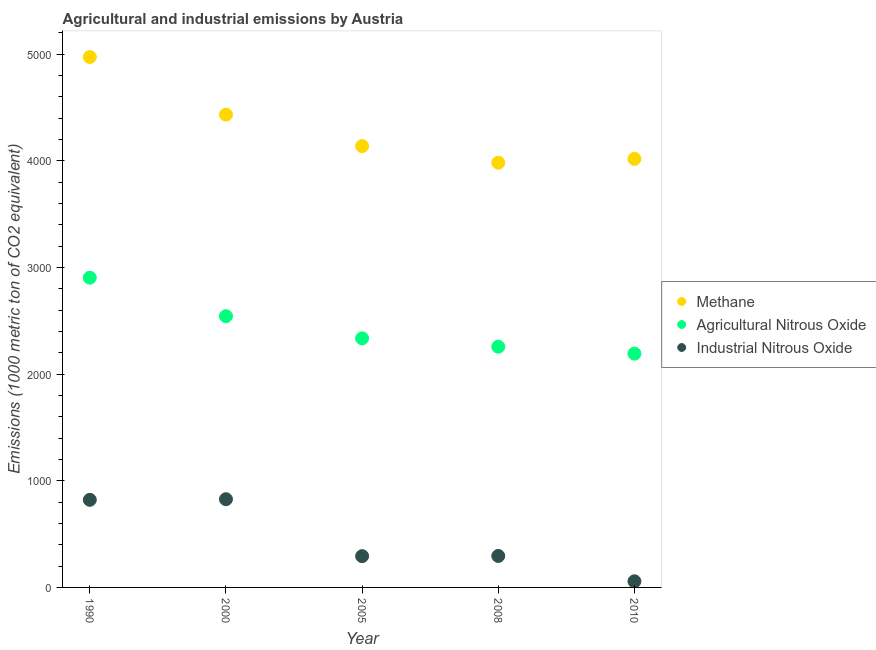What is the amount of agricultural nitrous oxide emissions in 2005?
Offer a very short reply. 2335.7. Across all years, what is the maximum amount of methane emissions?
Offer a terse response. 4973.8. Across all years, what is the minimum amount of agricultural nitrous oxide emissions?
Ensure brevity in your answer.  2192.3. In which year was the amount of methane emissions minimum?
Your answer should be compact. 2008. What is the total amount of industrial nitrous oxide emissions in the graph?
Make the answer very short. 2294.7. What is the difference between the amount of industrial nitrous oxide emissions in 2000 and that in 2008?
Provide a succinct answer. 532. What is the difference between the amount of industrial nitrous oxide emissions in 2000 and the amount of methane emissions in 2008?
Keep it short and to the point. -3155.6. What is the average amount of methane emissions per year?
Keep it short and to the point. 4309.52. In the year 1990, what is the difference between the amount of industrial nitrous oxide emissions and amount of methane emissions?
Offer a terse response. -4152.3. In how many years, is the amount of industrial nitrous oxide emissions greater than 3000 metric ton?
Your answer should be compact. 0. What is the ratio of the amount of methane emissions in 2005 to that in 2008?
Your answer should be very brief. 1.04. Is the amount of methane emissions in 1990 less than that in 2010?
Provide a succinct answer. No. What is the difference between the highest and the second highest amount of methane emissions?
Offer a terse response. 539.9. What is the difference between the highest and the lowest amount of industrial nitrous oxide emissions?
Provide a succinct answer. 769.7. In how many years, is the amount of industrial nitrous oxide emissions greater than the average amount of industrial nitrous oxide emissions taken over all years?
Your answer should be compact. 2. Is the amount of industrial nitrous oxide emissions strictly greater than the amount of methane emissions over the years?
Keep it short and to the point. No. How many dotlines are there?
Provide a short and direct response. 3. How many years are there in the graph?
Keep it short and to the point. 5. Are the values on the major ticks of Y-axis written in scientific E-notation?
Offer a very short reply. No. Does the graph contain grids?
Provide a short and direct response. No. Where does the legend appear in the graph?
Your answer should be very brief. Center right. How many legend labels are there?
Your response must be concise. 3. How are the legend labels stacked?
Your answer should be very brief. Vertical. What is the title of the graph?
Your answer should be very brief. Agricultural and industrial emissions by Austria. What is the label or title of the Y-axis?
Offer a terse response. Emissions (1000 metric ton of CO2 equivalent). What is the Emissions (1000 metric ton of CO2 equivalent) of Methane in 1990?
Keep it short and to the point. 4973.8. What is the Emissions (1000 metric ton of CO2 equivalent) in Agricultural Nitrous Oxide in 1990?
Your answer should be compact. 2904.8. What is the Emissions (1000 metric ton of CO2 equivalent) in Industrial Nitrous Oxide in 1990?
Your answer should be very brief. 821.5. What is the Emissions (1000 metric ton of CO2 equivalent) in Methane in 2000?
Make the answer very short. 4433.9. What is the Emissions (1000 metric ton of CO2 equivalent) of Agricultural Nitrous Oxide in 2000?
Your response must be concise. 2543.3. What is the Emissions (1000 metric ton of CO2 equivalent) of Industrial Nitrous Oxide in 2000?
Offer a very short reply. 827.2. What is the Emissions (1000 metric ton of CO2 equivalent) of Methane in 2005?
Offer a terse response. 4138.3. What is the Emissions (1000 metric ton of CO2 equivalent) of Agricultural Nitrous Oxide in 2005?
Provide a short and direct response. 2335.7. What is the Emissions (1000 metric ton of CO2 equivalent) of Industrial Nitrous Oxide in 2005?
Make the answer very short. 293.3. What is the Emissions (1000 metric ton of CO2 equivalent) of Methane in 2008?
Your answer should be compact. 3982.8. What is the Emissions (1000 metric ton of CO2 equivalent) in Agricultural Nitrous Oxide in 2008?
Ensure brevity in your answer.  2257.3. What is the Emissions (1000 metric ton of CO2 equivalent) of Industrial Nitrous Oxide in 2008?
Make the answer very short. 295.2. What is the Emissions (1000 metric ton of CO2 equivalent) in Methane in 2010?
Ensure brevity in your answer.  4018.8. What is the Emissions (1000 metric ton of CO2 equivalent) in Agricultural Nitrous Oxide in 2010?
Ensure brevity in your answer.  2192.3. What is the Emissions (1000 metric ton of CO2 equivalent) of Industrial Nitrous Oxide in 2010?
Provide a succinct answer. 57.5. Across all years, what is the maximum Emissions (1000 metric ton of CO2 equivalent) in Methane?
Provide a short and direct response. 4973.8. Across all years, what is the maximum Emissions (1000 metric ton of CO2 equivalent) in Agricultural Nitrous Oxide?
Give a very brief answer. 2904.8. Across all years, what is the maximum Emissions (1000 metric ton of CO2 equivalent) of Industrial Nitrous Oxide?
Offer a very short reply. 827.2. Across all years, what is the minimum Emissions (1000 metric ton of CO2 equivalent) of Methane?
Give a very brief answer. 3982.8. Across all years, what is the minimum Emissions (1000 metric ton of CO2 equivalent) of Agricultural Nitrous Oxide?
Give a very brief answer. 2192.3. Across all years, what is the minimum Emissions (1000 metric ton of CO2 equivalent) of Industrial Nitrous Oxide?
Offer a terse response. 57.5. What is the total Emissions (1000 metric ton of CO2 equivalent) in Methane in the graph?
Offer a terse response. 2.15e+04. What is the total Emissions (1000 metric ton of CO2 equivalent) of Agricultural Nitrous Oxide in the graph?
Keep it short and to the point. 1.22e+04. What is the total Emissions (1000 metric ton of CO2 equivalent) of Industrial Nitrous Oxide in the graph?
Offer a very short reply. 2294.7. What is the difference between the Emissions (1000 metric ton of CO2 equivalent) of Methane in 1990 and that in 2000?
Provide a succinct answer. 539.9. What is the difference between the Emissions (1000 metric ton of CO2 equivalent) of Agricultural Nitrous Oxide in 1990 and that in 2000?
Offer a very short reply. 361.5. What is the difference between the Emissions (1000 metric ton of CO2 equivalent) in Methane in 1990 and that in 2005?
Provide a succinct answer. 835.5. What is the difference between the Emissions (1000 metric ton of CO2 equivalent) of Agricultural Nitrous Oxide in 1990 and that in 2005?
Your answer should be compact. 569.1. What is the difference between the Emissions (1000 metric ton of CO2 equivalent) of Industrial Nitrous Oxide in 1990 and that in 2005?
Keep it short and to the point. 528.2. What is the difference between the Emissions (1000 metric ton of CO2 equivalent) of Methane in 1990 and that in 2008?
Your answer should be compact. 991. What is the difference between the Emissions (1000 metric ton of CO2 equivalent) of Agricultural Nitrous Oxide in 1990 and that in 2008?
Make the answer very short. 647.5. What is the difference between the Emissions (1000 metric ton of CO2 equivalent) in Industrial Nitrous Oxide in 1990 and that in 2008?
Your answer should be very brief. 526.3. What is the difference between the Emissions (1000 metric ton of CO2 equivalent) in Methane in 1990 and that in 2010?
Ensure brevity in your answer.  955. What is the difference between the Emissions (1000 metric ton of CO2 equivalent) in Agricultural Nitrous Oxide in 1990 and that in 2010?
Ensure brevity in your answer.  712.5. What is the difference between the Emissions (1000 metric ton of CO2 equivalent) in Industrial Nitrous Oxide in 1990 and that in 2010?
Provide a short and direct response. 764. What is the difference between the Emissions (1000 metric ton of CO2 equivalent) in Methane in 2000 and that in 2005?
Provide a short and direct response. 295.6. What is the difference between the Emissions (1000 metric ton of CO2 equivalent) in Agricultural Nitrous Oxide in 2000 and that in 2005?
Your answer should be very brief. 207.6. What is the difference between the Emissions (1000 metric ton of CO2 equivalent) in Industrial Nitrous Oxide in 2000 and that in 2005?
Offer a terse response. 533.9. What is the difference between the Emissions (1000 metric ton of CO2 equivalent) of Methane in 2000 and that in 2008?
Provide a succinct answer. 451.1. What is the difference between the Emissions (1000 metric ton of CO2 equivalent) of Agricultural Nitrous Oxide in 2000 and that in 2008?
Make the answer very short. 286. What is the difference between the Emissions (1000 metric ton of CO2 equivalent) in Industrial Nitrous Oxide in 2000 and that in 2008?
Your answer should be compact. 532. What is the difference between the Emissions (1000 metric ton of CO2 equivalent) of Methane in 2000 and that in 2010?
Your response must be concise. 415.1. What is the difference between the Emissions (1000 metric ton of CO2 equivalent) in Agricultural Nitrous Oxide in 2000 and that in 2010?
Provide a short and direct response. 351. What is the difference between the Emissions (1000 metric ton of CO2 equivalent) of Industrial Nitrous Oxide in 2000 and that in 2010?
Give a very brief answer. 769.7. What is the difference between the Emissions (1000 metric ton of CO2 equivalent) in Methane in 2005 and that in 2008?
Make the answer very short. 155.5. What is the difference between the Emissions (1000 metric ton of CO2 equivalent) in Agricultural Nitrous Oxide in 2005 and that in 2008?
Provide a short and direct response. 78.4. What is the difference between the Emissions (1000 metric ton of CO2 equivalent) of Methane in 2005 and that in 2010?
Offer a terse response. 119.5. What is the difference between the Emissions (1000 metric ton of CO2 equivalent) of Agricultural Nitrous Oxide in 2005 and that in 2010?
Make the answer very short. 143.4. What is the difference between the Emissions (1000 metric ton of CO2 equivalent) in Industrial Nitrous Oxide in 2005 and that in 2010?
Give a very brief answer. 235.8. What is the difference between the Emissions (1000 metric ton of CO2 equivalent) in Methane in 2008 and that in 2010?
Provide a short and direct response. -36. What is the difference between the Emissions (1000 metric ton of CO2 equivalent) of Agricultural Nitrous Oxide in 2008 and that in 2010?
Give a very brief answer. 65. What is the difference between the Emissions (1000 metric ton of CO2 equivalent) in Industrial Nitrous Oxide in 2008 and that in 2010?
Provide a short and direct response. 237.7. What is the difference between the Emissions (1000 metric ton of CO2 equivalent) in Methane in 1990 and the Emissions (1000 metric ton of CO2 equivalent) in Agricultural Nitrous Oxide in 2000?
Your answer should be compact. 2430.5. What is the difference between the Emissions (1000 metric ton of CO2 equivalent) of Methane in 1990 and the Emissions (1000 metric ton of CO2 equivalent) of Industrial Nitrous Oxide in 2000?
Your answer should be compact. 4146.6. What is the difference between the Emissions (1000 metric ton of CO2 equivalent) in Agricultural Nitrous Oxide in 1990 and the Emissions (1000 metric ton of CO2 equivalent) in Industrial Nitrous Oxide in 2000?
Provide a succinct answer. 2077.6. What is the difference between the Emissions (1000 metric ton of CO2 equivalent) in Methane in 1990 and the Emissions (1000 metric ton of CO2 equivalent) in Agricultural Nitrous Oxide in 2005?
Provide a short and direct response. 2638.1. What is the difference between the Emissions (1000 metric ton of CO2 equivalent) of Methane in 1990 and the Emissions (1000 metric ton of CO2 equivalent) of Industrial Nitrous Oxide in 2005?
Offer a terse response. 4680.5. What is the difference between the Emissions (1000 metric ton of CO2 equivalent) in Agricultural Nitrous Oxide in 1990 and the Emissions (1000 metric ton of CO2 equivalent) in Industrial Nitrous Oxide in 2005?
Your response must be concise. 2611.5. What is the difference between the Emissions (1000 metric ton of CO2 equivalent) in Methane in 1990 and the Emissions (1000 metric ton of CO2 equivalent) in Agricultural Nitrous Oxide in 2008?
Ensure brevity in your answer.  2716.5. What is the difference between the Emissions (1000 metric ton of CO2 equivalent) in Methane in 1990 and the Emissions (1000 metric ton of CO2 equivalent) in Industrial Nitrous Oxide in 2008?
Keep it short and to the point. 4678.6. What is the difference between the Emissions (1000 metric ton of CO2 equivalent) in Agricultural Nitrous Oxide in 1990 and the Emissions (1000 metric ton of CO2 equivalent) in Industrial Nitrous Oxide in 2008?
Provide a succinct answer. 2609.6. What is the difference between the Emissions (1000 metric ton of CO2 equivalent) of Methane in 1990 and the Emissions (1000 metric ton of CO2 equivalent) of Agricultural Nitrous Oxide in 2010?
Ensure brevity in your answer.  2781.5. What is the difference between the Emissions (1000 metric ton of CO2 equivalent) of Methane in 1990 and the Emissions (1000 metric ton of CO2 equivalent) of Industrial Nitrous Oxide in 2010?
Your answer should be very brief. 4916.3. What is the difference between the Emissions (1000 metric ton of CO2 equivalent) in Agricultural Nitrous Oxide in 1990 and the Emissions (1000 metric ton of CO2 equivalent) in Industrial Nitrous Oxide in 2010?
Your answer should be compact. 2847.3. What is the difference between the Emissions (1000 metric ton of CO2 equivalent) of Methane in 2000 and the Emissions (1000 metric ton of CO2 equivalent) of Agricultural Nitrous Oxide in 2005?
Provide a short and direct response. 2098.2. What is the difference between the Emissions (1000 metric ton of CO2 equivalent) of Methane in 2000 and the Emissions (1000 metric ton of CO2 equivalent) of Industrial Nitrous Oxide in 2005?
Make the answer very short. 4140.6. What is the difference between the Emissions (1000 metric ton of CO2 equivalent) of Agricultural Nitrous Oxide in 2000 and the Emissions (1000 metric ton of CO2 equivalent) of Industrial Nitrous Oxide in 2005?
Your answer should be very brief. 2250. What is the difference between the Emissions (1000 metric ton of CO2 equivalent) of Methane in 2000 and the Emissions (1000 metric ton of CO2 equivalent) of Agricultural Nitrous Oxide in 2008?
Ensure brevity in your answer.  2176.6. What is the difference between the Emissions (1000 metric ton of CO2 equivalent) in Methane in 2000 and the Emissions (1000 metric ton of CO2 equivalent) in Industrial Nitrous Oxide in 2008?
Give a very brief answer. 4138.7. What is the difference between the Emissions (1000 metric ton of CO2 equivalent) in Agricultural Nitrous Oxide in 2000 and the Emissions (1000 metric ton of CO2 equivalent) in Industrial Nitrous Oxide in 2008?
Your response must be concise. 2248.1. What is the difference between the Emissions (1000 metric ton of CO2 equivalent) of Methane in 2000 and the Emissions (1000 metric ton of CO2 equivalent) of Agricultural Nitrous Oxide in 2010?
Your answer should be compact. 2241.6. What is the difference between the Emissions (1000 metric ton of CO2 equivalent) of Methane in 2000 and the Emissions (1000 metric ton of CO2 equivalent) of Industrial Nitrous Oxide in 2010?
Your response must be concise. 4376.4. What is the difference between the Emissions (1000 metric ton of CO2 equivalent) of Agricultural Nitrous Oxide in 2000 and the Emissions (1000 metric ton of CO2 equivalent) of Industrial Nitrous Oxide in 2010?
Your answer should be compact. 2485.8. What is the difference between the Emissions (1000 metric ton of CO2 equivalent) of Methane in 2005 and the Emissions (1000 metric ton of CO2 equivalent) of Agricultural Nitrous Oxide in 2008?
Offer a very short reply. 1881. What is the difference between the Emissions (1000 metric ton of CO2 equivalent) of Methane in 2005 and the Emissions (1000 metric ton of CO2 equivalent) of Industrial Nitrous Oxide in 2008?
Provide a short and direct response. 3843.1. What is the difference between the Emissions (1000 metric ton of CO2 equivalent) of Agricultural Nitrous Oxide in 2005 and the Emissions (1000 metric ton of CO2 equivalent) of Industrial Nitrous Oxide in 2008?
Offer a terse response. 2040.5. What is the difference between the Emissions (1000 metric ton of CO2 equivalent) of Methane in 2005 and the Emissions (1000 metric ton of CO2 equivalent) of Agricultural Nitrous Oxide in 2010?
Provide a short and direct response. 1946. What is the difference between the Emissions (1000 metric ton of CO2 equivalent) in Methane in 2005 and the Emissions (1000 metric ton of CO2 equivalent) in Industrial Nitrous Oxide in 2010?
Your answer should be compact. 4080.8. What is the difference between the Emissions (1000 metric ton of CO2 equivalent) of Agricultural Nitrous Oxide in 2005 and the Emissions (1000 metric ton of CO2 equivalent) of Industrial Nitrous Oxide in 2010?
Give a very brief answer. 2278.2. What is the difference between the Emissions (1000 metric ton of CO2 equivalent) in Methane in 2008 and the Emissions (1000 metric ton of CO2 equivalent) in Agricultural Nitrous Oxide in 2010?
Keep it short and to the point. 1790.5. What is the difference between the Emissions (1000 metric ton of CO2 equivalent) of Methane in 2008 and the Emissions (1000 metric ton of CO2 equivalent) of Industrial Nitrous Oxide in 2010?
Provide a succinct answer. 3925.3. What is the difference between the Emissions (1000 metric ton of CO2 equivalent) of Agricultural Nitrous Oxide in 2008 and the Emissions (1000 metric ton of CO2 equivalent) of Industrial Nitrous Oxide in 2010?
Give a very brief answer. 2199.8. What is the average Emissions (1000 metric ton of CO2 equivalent) in Methane per year?
Offer a very short reply. 4309.52. What is the average Emissions (1000 metric ton of CO2 equivalent) of Agricultural Nitrous Oxide per year?
Offer a terse response. 2446.68. What is the average Emissions (1000 metric ton of CO2 equivalent) of Industrial Nitrous Oxide per year?
Offer a terse response. 458.94. In the year 1990, what is the difference between the Emissions (1000 metric ton of CO2 equivalent) in Methane and Emissions (1000 metric ton of CO2 equivalent) in Agricultural Nitrous Oxide?
Make the answer very short. 2069. In the year 1990, what is the difference between the Emissions (1000 metric ton of CO2 equivalent) in Methane and Emissions (1000 metric ton of CO2 equivalent) in Industrial Nitrous Oxide?
Your answer should be compact. 4152.3. In the year 1990, what is the difference between the Emissions (1000 metric ton of CO2 equivalent) in Agricultural Nitrous Oxide and Emissions (1000 metric ton of CO2 equivalent) in Industrial Nitrous Oxide?
Provide a succinct answer. 2083.3. In the year 2000, what is the difference between the Emissions (1000 metric ton of CO2 equivalent) of Methane and Emissions (1000 metric ton of CO2 equivalent) of Agricultural Nitrous Oxide?
Offer a very short reply. 1890.6. In the year 2000, what is the difference between the Emissions (1000 metric ton of CO2 equivalent) of Methane and Emissions (1000 metric ton of CO2 equivalent) of Industrial Nitrous Oxide?
Provide a succinct answer. 3606.7. In the year 2000, what is the difference between the Emissions (1000 metric ton of CO2 equivalent) of Agricultural Nitrous Oxide and Emissions (1000 metric ton of CO2 equivalent) of Industrial Nitrous Oxide?
Provide a succinct answer. 1716.1. In the year 2005, what is the difference between the Emissions (1000 metric ton of CO2 equivalent) of Methane and Emissions (1000 metric ton of CO2 equivalent) of Agricultural Nitrous Oxide?
Your answer should be compact. 1802.6. In the year 2005, what is the difference between the Emissions (1000 metric ton of CO2 equivalent) in Methane and Emissions (1000 metric ton of CO2 equivalent) in Industrial Nitrous Oxide?
Your response must be concise. 3845. In the year 2005, what is the difference between the Emissions (1000 metric ton of CO2 equivalent) of Agricultural Nitrous Oxide and Emissions (1000 metric ton of CO2 equivalent) of Industrial Nitrous Oxide?
Provide a short and direct response. 2042.4. In the year 2008, what is the difference between the Emissions (1000 metric ton of CO2 equivalent) in Methane and Emissions (1000 metric ton of CO2 equivalent) in Agricultural Nitrous Oxide?
Your answer should be compact. 1725.5. In the year 2008, what is the difference between the Emissions (1000 metric ton of CO2 equivalent) of Methane and Emissions (1000 metric ton of CO2 equivalent) of Industrial Nitrous Oxide?
Provide a succinct answer. 3687.6. In the year 2008, what is the difference between the Emissions (1000 metric ton of CO2 equivalent) of Agricultural Nitrous Oxide and Emissions (1000 metric ton of CO2 equivalent) of Industrial Nitrous Oxide?
Provide a succinct answer. 1962.1. In the year 2010, what is the difference between the Emissions (1000 metric ton of CO2 equivalent) of Methane and Emissions (1000 metric ton of CO2 equivalent) of Agricultural Nitrous Oxide?
Keep it short and to the point. 1826.5. In the year 2010, what is the difference between the Emissions (1000 metric ton of CO2 equivalent) of Methane and Emissions (1000 metric ton of CO2 equivalent) of Industrial Nitrous Oxide?
Ensure brevity in your answer.  3961.3. In the year 2010, what is the difference between the Emissions (1000 metric ton of CO2 equivalent) in Agricultural Nitrous Oxide and Emissions (1000 metric ton of CO2 equivalent) in Industrial Nitrous Oxide?
Ensure brevity in your answer.  2134.8. What is the ratio of the Emissions (1000 metric ton of CO2 equivalent) in Methane in 1990 to that in 2000?
Your answer should be compact. 1.12. What is the ratio of the Emissions (1000 metric ton of CO2 equivalent) of Agricultural Nitrous Oxide in 1990 to that in 2000?
Your answer should be compact. 1.14. What is the ratio of the Emissions (1000 metric ton of CO2 equivalent) of Industrial Nitrous Oxide in 1990 to that in 2000?
Provide a succinct answer. 0.99. What is the ratio of the Emissions (1000 metric ton of CO2 equivalent) in Methane in 1990 to that in 2005?
Offer a terse response. 1.2. What is the ratio of the Emissions (1000 metric ton of CO2 equivalent) in Agricultural Nitrous Oxide in 1990 to that in 2005?
Ensure brevity in your answer.  1.24. What is the ratio of the Emissions (1000 metric ton of CO2 equivalent) of Industrial Nitrous Oxide in 1990 to that in 2005?
Provide a succinct answer. 2.8. What is the ratio of the Emissions (1000 metric ton of CO2 equivalent) in Methane in 1990 to that in 2008?
Your answer should be compact. 1.25. What is the ratio of the Emissions (1000 metric ton of CO2 equivalent) in Agricultural Nitrous Oxide in 1990 to that in 2008?
Your answer should be very brief. 1.29. What is the ratio of the Emissions (1000 metric ton of CO2 equivalent) of Industrial Nitrous Oxide in 1990 to that in 2008?
Your answer should be very brief. 2.78. What is the ratio of the Emissions (1000 metric ton of CO2 equivalent) of Methane in 1990 to that in 2010?
Give a very brief answer. 1.24. What is the ratio of the Emissions (1000 metric ton of CO2 equivalent) of Agricultural Nitrous Oxide in 1990 to that in 2010?
Provide a succinct answer. 1.32. What is the ratio of the Emissions (1000 metric ton of CO2 equivalent) of Industrial Nitrous Oxide in 1990 to that in 2010?
Ensure brevity in your answer.  14.29. What is the ratio of the Emissions (1000 metric ton of CO2 equivalent) of Methane in 2000 to that in 2005?
Provide a short and direct response. 1.07. What is the ratio of the Emissions (1000 metric ton of CO2 equivalent) of Agricultural Nitrous Oxide in 2000 to that in 2005?
Provide a short and direct response. 1.09. What is the ratio of the Emissions (1000 metric ton of CO2 equivalent) in Industrial Nitrous Oxide in 2000 to that in 2005?
Give a very brief answer. 2.82. What is the ratio of the Emissions (1000 metric ton of CO2 equivalent) in Methane in 2000 to that in 2008?
Make the answer very short. 1.11. What is the ratio of the Emissions (1000 metric ton of CO2 equivalent) of Agricultural Nitrous Oxide in 2000 to that in 2008?
Give a very brief answer. 1.13. What is the ratio of the Emissions (1000 metric ton of CO2 equivalent) of Industrial Nitrous Oxide in 2000 to that in 2008?
Your response must be concise. 2.8. What is the ratio of the Emissions (1000 metric ton of CO2 equivalent) in Methane in 2000 to that in 2010?
Your answer should be compact. 1.1. What is the ratio of the Emissions (1000 metric ton of CO2 equivalent) of Agricultural Nitrous Oxide in 2000 to that in 2010?
Your answer should be very brief. 1.16. What is the ratio of the Emissions (1000 metric ton of CO2 equivalent) of Industrial Nitrous Oxide in 2000 to that in 2010?
Provide a short and direct response. 14.39. What is the ratio of the Emissions (1000 metric ton of CO2 equivalent) of Methane in 2005 to that in 2008?
Your answer should be compact. 1.04. What is the ratio of the Emissions (1000 metric ton of CO2 equivalent) in Agricultural Nitrous Oxide in 2005 to that in 2008?
Offer a very short reply. 1.03. What is the ratio of the Emissions (1000 metric ton of CO2 equivalent) of Methane in 2005 to that in 2010?
Give a very brief answer. 1.03. What is the ratio of the Emissions (1000 metric ton of CO2 equivalent) in Agricultural Nitrous Oxide in 2005 to that in 2010?
Ensure brevity in your answer.  1.07. What is the ratio of the Emissions (1000 metric ton of CO2 equivalent) of Industrial Nitrous Oxide in 2005 to that in 2010?
Your answer should be very brief. 5.1. What is the ratio of the Emissions (1000 metric ton of CO2 equivalent) in Agricultural Nitrous Oxide in 2008 to that in 2010?
Give a very brief answer. 1.03. What is the ratio of the Emissions (1000 metric ton of CO2 equivalent) of Industrial Nitrous Oxide in 2008 to that in 2010?
Provide a short and direct response. 5.13. What is the difference between the highest and the second highest Emissions (1000 metric ton of CO2 equivalent) of Methane?
Provide a short and direct response. 539.9. What is the difference between the highest and the second highest Emissions (1000 metric ton of CO2 equivalent) in Agricultural Nitrous Oxide?
Ensure brevity in your answer.  361.5. What is the difference between the highest and the second highest Emissions (1000 metric ton of CO2 equivalent) of Industrial Nitrous Oxide?
Your response must be concise. 5.7. What is the difference between the highest and the lowest Emissions (1000 metric ton of CO2 equivalent) of Methane?
Provide a succinct answer. 991. What is the difference between the highest and the lowest Emissions (1000 metric ton of CO2 equivalent) of Agricultural Nitrous Oxide?
Make the answer very short. 712.5. What is the difference between the highest and the lowest Emissions (1000 metric ton of CO2 equivalent) in Industrial Nitrous Oxide?
Give a very brief answer. 769.7. 